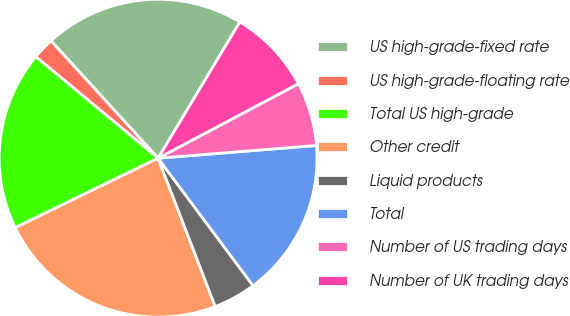Convert chart. <chart><loc_0><loc_0><loc_500><loc_500><pie_chart><fcel>US high-grade-fixed rate<fcel>US high-grade-floating rate<fcel>Total US high-grade<fcel>Other credit<fcel>Liquid products<fcel>Total<fcel>Number of US trading days<fcel>Number of UK trading days<nl><fcel>20.38%<fcel>2.2%<fcel>18.23%<fcel>23.65%<fcel>4.34%<fcel>16.09%<fcel>6.49%<fcel>8.63%<nl></chart> 